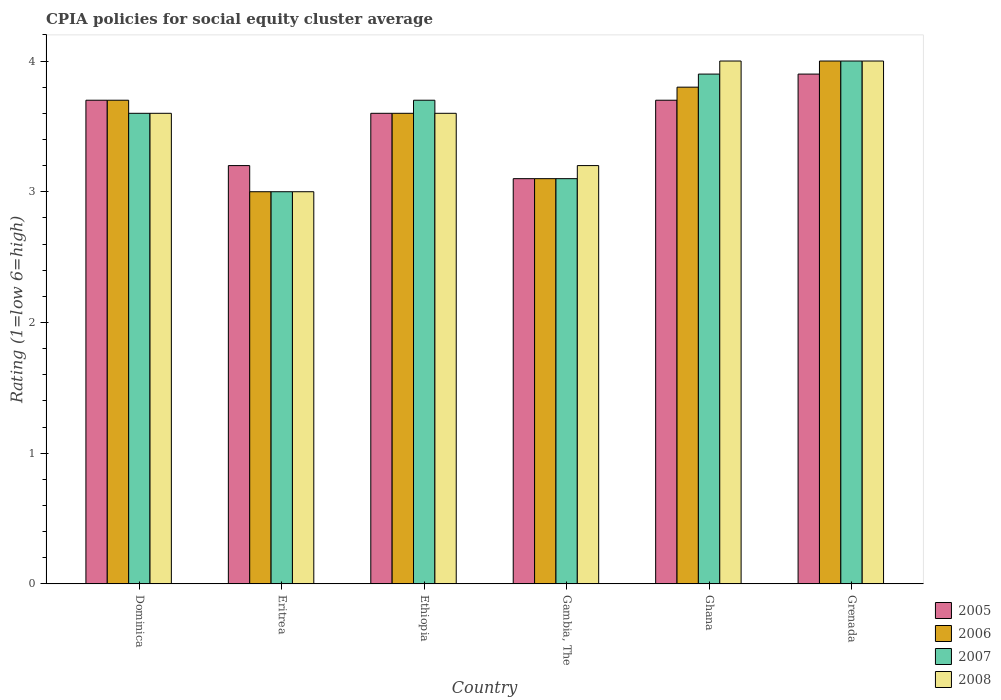How many different coloured bars are there?
Your response must be concise. 4. How many groups of bars are there?
Provide a short and direct response. 6. Are the number of bars on each tick of the X-axis equal?
Provide a succinct answer. Yes. How many bars are there on the 2nd tick from the left?
Provide a succinct answer. 4. How many bars are there on the 4th tick from the right?
Give a very brief answer. 4. What is the label of the 3rd group of bars from the left?
Your answer should be very brief. Ethiopia. In how many cases, is the number of bars for a given country not equal to the number of legend labels?
Your answer should be very brief. 0. What is the CPIA rating in 2005 in Gambia, The?
Provide a short and direct response. 3.1. Across all countries, what is the minimum CPIA rating in 2005?
Give a very brief answer. 3.1. In which country was the CPIA rating in 2005 maximum?
Your response must be concise. Grenada. In which country was the CPIA rating in 2005 minimum?
Offer a very short reply. Gambia, The. What is the total CPIA rating in 2005 in the graph?
Offer a terse response. 21.2. What is the difference between the CPIA rating in 2007 in Ethiopia and that in Gambia, The?
Your response must be concise. 0.6. What is the difference between the CPIA rating in 2006 in Ethiopia and the CPIA rating in 2005 in Ghana?
Your response must be concise. -0.1. What is the average CPIA rating in 2005 per country?
Your answer should be very brief. 3.53. What is the ratio of the CPIA rating in 2006 in Eritrea to that in Gambia, The?
Provide a short and direct response. 0.97. Is the CPIA rating in 2005 in Eritrea less than that in Ethiopia?
Offer a very short reply. Yes. What is the difference between the highest and the second highest CPIA rating in 2005?
Offer a very short reply. -0.2. In how many countries, is the CPIA rating in 2008 greater than the average CPIA rating in 2008 taken over all countries?
Provide a short and direct response. 4. What does the 1st bar from the left in Gambia, The represents?
Your answer should be compact. 2005. Is it the case that in every country, the sum of the CPIA rating in 2006 and CPIA rating in 2005 is greater than the CPIA rating in 2007?
Your answer should be compact. Yes. How many bars are there?
Your response must be concise. 24. Are the values on the major ticks of Y-axis written in scientific E-notation?
Provide a succinct answer. No. Does the graph contain any zero values?
Offer a very short reply. No. Does the graph contain grids?
Keep it short and to the point. No. How are the legend labels stacked?
Offer a terse response. Vertical. What is the title of the graph?
Your answer should be very brief. CPIA policies for social equity cluster average. What is the label or title of the X-axis?
Ensure brevity in your answer.  Country. What is the Rating (1=low 6=high) of 2005 in Dominica?
Your answer should be compact. 3.7. What is the Rating (1=low 6=high) in 2005 in Eritrea?
Keep it short and to the point. 3.2. What is the Rating (1=low 6=high) in 2006 in Eritrea?
Your answer should be very brief. 3. What is the Rating (1=low 6=high) of 2006 in Ethiopia?
Ensure brevity in your answer.  3.6. What is the Rating (1=low 6=high) in 2005 in Gambia, The?
Keep it short and to the point. 3.1. What is the Rating (1=low 6=high) in 2008 in Gambia, The?
Provide a succinct answer. 3.2. What is the Rating (1=low 6=high) in 2007 in Ghana?
Your answer should be very brief. 3.9. What is the Rating (1=low 6=high) of 2005 in Grenada?
Give a very brief answer. 3.9. What is the Rating (1=low 6=high) in 2007 in Grenada?
Offer a terse response. 4. Across all countries, what is the maximum Rating (1=low 6=high) in 2007?
Offer a terse response. 4. Across all countries, what is the minimum Rating (1=low 6=high) in 2006?
Your answer should be very brief. 3. Across all countries, what is the minimum Rating (1=low 6=high) in 2008?
Provide a short and direct response. 3. What is the total Rating (1=low 6=high) in 2005 in the graph?
Make the answer very short. 21.2. What is the total Rating (1=low 6=high) in 2006 in the graph?
Provide a succinct answer. 21.2. What is the total Rating (1=low 6=high) in 2007 in the graph?
Offer a very short reply. 21.3. What is the total Rating (1=low 6=high) in 2008 in the graph?
Offer a terse response. 21.4. What is the difference between the Rating (1=low 6=high) of 2005 in Dominica and that in Eritrea?
Provide a short and direct response. 0.5. What is the difference between the Rating (1=low 6=high) in 2007 in Dominica and that in Eritrea?
Your answer should be compact. 0.6. What is the difference between the Rating (1=low 6=high) of 2006 in Dominica and that in Ethiopia?
Your answer should be compact. 0.1. What is the difference between the Rating (1=low 6=high) of 2006 in Dominica and that in Gambia, The?
Your answer should be very brief. 0.6. What is the difference between the Rating (1=low 6=high) in 2007 in Dominica and that in Gambia, The?
Give a very brief answer. 0.5. What is the difference between the Rating (1=low 6=high) of 2006 in Dominica and that in Ghana?
Give a very brief answer. -0.1. What is the difference between the Rating (1=low 6=high) in 2007 in Dominica and that in Ghana?
Provide a succinct answer. -0.3. What is the difference between the Rating (1=low 6=high) in 2005 in Dominica and that in Grenada?
Provide a short and direct response. -0.2. What is the difference between the Rating (1=low 6=high) of 2006 in Dominica and that in Grenada?
Keep it short and to the point. -0.3. What is the difference between the Rating (1=low 6=high) of 2007 in Dominica and that in Grenada?
Provide a succinct answer. -0.4. What is the difference between the Rating (1=low 6=high) in 2005 in Eritrea and that in Gambia, The?
Your answer should be very brief. 0.1. What is the difference between the Rating (1=low 6=high) in 2006 in Eritrea and that in Gambia, The?
Give a very brief answer. -0.1. What is the difference between the Rating (1=low 6=high) in 2008 in Eritrea and that in Gambia, The?
Keep it short and to the point. -0.2. What is the difference between the Rating (1=low 6=high) of 2005 in Eritrea and that in Ghana?
Give a very brief answer. -0.5. What is the difference between the Rating (1=low 6=high) of 2006 in Eritrea and that in Ghana?
Make the answer very short. -0.8. What is the difference between the Rating (1=low 6=high) in 2008 in Eritrea and that in Ghana?
Ensure brevity in your answer.  -1. What is the difference between the Rating (1=low 6=high) in 2006 in Eritrea and that in Grenada?
Offer a very short reply. -1. What is the difference between the Rating (1=low 6=high) of 2008 in Eritrea and that in Grenada?
Your answer should be compact. -1. What is the difference between the Rating (1=low 6=high) in 2005 in Ethiopia and that in Gambia, The?
Provide a succinct answer. 0.5. What is the difference between the Rating (1=low 6=high) of 2008 in Ethiopia and that in Gambia, The?
Provide a succinct answer. 0.4. What is the difference between the Rating (1=low 6=high) of 2005 in Ethiopia and that in Ghana?
Make the answer very short. -0.1. What is the difference between the Rating (1=low 6=high) in 2008 in Ethiopia and that in Ghana?
Keep it short and to the point. -0.4. What is the difference between the Rating (1=low 6=high) in 2005 in Ethiopia and that in Grenada?
Offer a terse response. -0.3. What is the difference between the Rating (1=low 6=high) in 2007 in Ethiopia and that in Grenada?
Provide a short and direct response. -0.3. What is the difference between the Rating (1=low 6=high) in 2006 in Gambia, The and that in Ghana?
Provide a short and direct response. -0.7. What is the difference between the Rating (1=low 6=high) of 2008 in Gambia, The and that in Ghana?
Provide a short and direct response. -0.8. What is the difference between the Rating (1=low 6=high) in 2005 in Ghana and that in Grenada?
Your answer should be compact. -0.2. What is the difference between the Rating (1=low 6=high) of 2007 in Ghana and that in Grenada?
Offer a terse response. -0.1. What is the difference between the Rating (1=low 6=high) in 2005 in Dominica and the Rating (1=low 6=high) in 2007 in Eritrea?
Your answer should be compact. 0.7. What is the difference between the Rating (1=low 6=high) in 2005 in Dominica and the Rating (1=low 6=high) in 2008 in Eritrea?
Offer a very short reply. 0.7. What is the difference between the Rating (1=low 6=high) in 2005 in Dominica and the Rating (1=low 6=high) in 2006 in Ethiopia?
Offer a very short reply. 0.1. What is the difference between the Rating (1=low 6=high) in 2005 in Dominica and the Rating (1=low 6=high) in 2007 in Ethiopia?
Make the answer very short. 0. What is the difference between the Rating (1=low 6=high) of 2006 in Dominica and the Rating (1=low 6=high) of 2007 in Ethiopia?
Your answer should be very brief. 0. What is the difference between the Rating (1=low 6=high) in 2007 in Dominica and the Rating (1=low 6=high) in 2008 in Ethiopia?
Make the answer very short. 0. What is the difference between the Rating (1=low 6=high) of 2005 in Dominica and the Rating (1=low 6=high) of 2006 in Gambia, The?
Provide a succinct answer. 0.6. What is the difference between the Rating (1=low 6=high) in 2007 in Dominica and the Rating (1=low 6=high) in 2008 in Gambia, The?
Keep it short and to the point. 0.4. What is the difference between the Rating (1=low 6=high) of 2005 in Dominica and the Rating (1=low 6=high) of 2006 in Ghana?
Make the answer very short. -0.1. What is the difference between the Rating (1=low 6=high) in 2005 in Dominica and the Rating (1=low 6=high) in 2008 in Ghana?
Offer a very short reply. -0.3. What is the difference between the Rating (1=low 6=high) of 2006 in Dominica and the Rating (1=low 6=high) of 2007 in Ghana?
Your answer should be very brief. -0.2. What is the difference between the Rating (1=low 6=high) of 2006 in Dominica and the Rating (1=low 6=high) of 2008 in Ghana?
Your answer should be very brief. -0.3. What is the difference between the Rating (1=low 6=high) of 2007 in Dominica and the Rating (1=low 6=high) of 2008 in Ghana?
Keep it short and to the point. -0.4. What is the difference between the Rating (1=low 6=high) of 2006 in Dominica and the Rating (1=low 6=high) of 2007 in Grenada?
Your response must be concise. -0.3. What is the difference between the Rating (1=low 6=high) in 2005 in Eritrea and the Rating (1=low 6=high) in 2006 in Ethiopia?
Your answer should be very brief. -0.4. What is the difference between the Rating (1=low 6=high) in 2005 in Eritrea and the Rating (1=low 6=high) in 2007 in Ethiopia?
Your answer should be compact. -0.5. What is the difference between the Rating (1=low 6=high) in 2006 in Eritrea and the Rating (1=low 6=high) in 2007 in Ethiopia?
Your answer should be very brief. -0.7. What is the difference between the Rating (1=low 6=high) of 2007 in Eritrea and the Rating (1=low 6=high) of 2008 in Ethiopia?
Ensure brevity in your answer.  -0.6. What is the difference between the Rating (1=low 6=high) in 2005 in Eritrea and the Rating (1=low 6=high) in 2006 in Gambia, The?
Make the answer very short. 0.1. What is the difference between the Rating (1=low 6=high) in 2005 in Eritrea and the Rating (1=low 6=high) in 2008 in Gambia, The?
Make the answer very short. 0. What is the difference between the Rating (1=low 6=high) in 2006 in Eritrea and the Rating (1=low 6=high) in 2007 in Gambia, The?
Offer a terse response. -0.1. What is the difference between the Rating (1=low 6=high) in 2007 in Eritrea and the Rating (1=low 6=high) in 2008 in Gambia, The?
Give a very brief answer. -0.2. What is the difference between the Rating (1=low 6=high) of 2005 in Eritrea and the Rating (1=low 6=high) of 2007 in Ghana?
Your answer should be compact. -0.7. What is the difference between the Rating (1=low 6=high) in 2006 in Eritrea and the Rating (1=low 6=high) in 2007 in Ghana?
Provide a short and direct response. -0.9. What is the difference between the Rating (1=low 6=high) in 2007 in Eritrea and the Rating (1=low 6=high) in 2008 in Ghana?
Provide a succinct answer. -1. What is the difference between the Rating (1=low 6=high) of 2006 in Eritrea and the Rating (1=low 6=high) of 2007 in Grenada?
Offer a very short reply. -1. What is the difference between the Rating (1=low 6=high) of 2006 in Eritrea and the Rating (1=low 6=high) of 2008 in Grenada?
Your response must be concise. -1. What is the difference between the Rating (1=low 6=high) in 2007 in Eritrea and the Rating (1=low 6=high) in 2008 in Grenada?
Offer a very short reply. -1. What is the difference between the Rating (1=low 6=high) of 2005 in Ethiopia and the Rating (1=low 6=high) of 2006 in Gambia, The?
Ensure brevity in your answer.  0.5. What is the difference between the Rating (1=low 6=high) of 2005 in Ethiopia and the Rating (1=low 6=high) of 2008 in Gambia, The?
Provide a succinct answer. 0.4. What is the difference between the Rating (1=low 6=high) in 2006 in Ethiopia and the Rating (1=low 6=high) in 2008 in Gambia, The?
Ensure brevity in your answer.  0.4. What is the difference between the Rating (1=low 6=high) in 2007 in Ethiopia and the Rating (1=low 6=high) in 2008 in Gambia, The?
Offer a terse response. 0.5. What is the difference between the Rating (1=low 6=high) of 2005 in Ethiopia and the Rating (1=low 6=high) of 2006 in Ghana?
Ensure brevity in your answer.  -0.2. What is the difference between the Rating (1=low 6=high) in 2005 in Ethiopia and the Rating (1=low 6=high) in 2008 in Ghana?
Offer a very short reply. -0.4. What is the difference between the Rating (1=low 6=high) in 2006 in Ethiopia and the Rating (1=low 6=high) in 2008 in Ghana?
Keep it short and to the point. -0.4. What is the difference between the Rating (1=low 6=high) of 2007 in Ethiopia and the Rating (1=low 6=high) of 2008 in Ghana?
Your answer should be very brief. -0.3. What is the difference between the Rating (1=low 6=high) of 2005 in Ethiopia and the Rating (1=low 6=high) of 2006 in Grenada?
Ensure brevity in your answer.  -0.4. What is the difference between the Rating (1=low 6=high) in 2005 in Ethiopia and the Rating (1=low 6=high) in 2007 in Grenada?
Provide a short and direct response. -0.4. What is the difference between the Rating (1=low 6=high) of 2005 in Ethiopia and the Rating (1=low 6=high) of 2008 in Grenada?
Keep it short and to the point. -0.4. What is the difference between the Rating (1=low 6=high) of 2006 in Ethiopia and the Rating (1=low 6=high) of 2007 in Grenada?
Make the answer very short. -0.4. What is the difference between the Rating (1=low 6=high) in 2006 in Ethiopia and the Rating (1=low 6=high) in 2008 in Grenada?
Give a very brief answer. -0.4. What is the difference between the Rating (1=low 6=high) of 2005 in Gambia, The and the Rating (1=low 6=high) of 2008 in Ghana?
Keep it short and to the point. -0.9. What is the difference between the Rating (1=low 6=high) of 2006 in Gambia, The and the Rating (1=low 6=high) of 2008 in Ghana?
Offer a very short reply. -0.9. What is the difference between the Rating (1=low 6=high) in 2007 in Gambia, The and the Rating (1=low 6=high) in 2008 in Ghana?
Give a very brief answer. -0.9. What is the difference between the Rating (1=low 6=high) of 2005 in Gambia, The and the Rating (1=low 6=high) of 2006 in Grenada?
Your response must be concise. -0.9. What is the difference between the Rating (1=low 6=high) of 2006 in Gambia, The and the Rating (1=low 6=high) of 2007 in Grenada?
Offer a terse response. -0.9. What is the difference between the Rating (1=low 6=high) in 2007 in Gambia, The and the Rating (1=low 6=high) in 2008 in Grenada?
Ensure brevity in your answer.  -0.9. What is the difference between the Rating (1=low 6=high) of 2005 in Ghana and the Rating (1=low 6=high) of 2007 in Grenada?
Your answer should be compact. -0.3. What is the difference between the Rating (1=low 6=high) in 2006 in Ghana and the Rating (1=low 6=high) in 2007 in Grenada?
Provide a short and direct response. -0.2. What is the difference between the Rating (1=low 6=high) of 2007 in Ghana and the Rating (1=low 6=high) of 2008 in Grenada?
Your answer should be compact. -0.1. What is the average Rating (1=low 6=high) in 2005 per country?
Your answer should be compact. 3.53. What is the average Rating (1=low 6=high) of 2006 per country?
Offer a very short reply. 3.53. What is the average Rating (1=low 6=high) in 2007 per country?
Offer a terse response. 3.55. What is the average Rating (1=low 6=high) of 2008 per country?
Keep it short and to the point. 3.57. What is the difference between the Rating (1=low 6=high) of 2005 and Rating (1=low 6=high) of 2006 in Dominica?
Provide a succinct answer. 0. What is the difference between the Rating (1=low 6=high) in 2005 and Rating (1=low 6=high) in 2007 in Dominica?
Offer a terse response. 0.1. What is the difference between the Rating (1=low 6=high) of 2007 and Rating (1=low 6=high) of 2008 in Dominica?
Keep it short and to the point. 0. What is the difference between the Rating (1=low 6=high) of 2005 and Rating (1=low 6=high) of 2007 in Eritrea?
Give a very brief answer. 0.2. What is the difference between the Rating (1=low 6=high) of 2005 and Rating (1=low 6=high) of 2008 in Eritrea?
Provide a succinct answer. 0.2. What is the difference between the Rating (1=low 6=high) in 2006 and Rating (1=low 6=high) in 2007 in Eritrea?
Keep it short and to the point. 0. What is the difference between the Rating (1=low 6=high) in 2005 and Rating (1=low 6=high) in 2007 in Ethiopia?
Ensure brevity in your answer.  -0.1. What is the difference between the Rating (1=low 6=high) of 2005 and Rating (1=low 6=high) of 2008 in Ethiopia?
Offer a very short reply. 0. What is the difference between the Rating (1=low 6=high) of 2006 and Rating (1=low 6=high) of 2007 in Ethiopia?
Offer a terse response. -0.1. What is the difference between the Rating (1=low 6=high) of 2005 and Rating (1=low 6=high) of 2006 in Gambia, The?
Your answer should be very brief. 0. What is the difference between the Rating (1=low 6=high) in 2005 and Rating (1=low 6=high) in 2008 in Gambia, The?
Your answer should be very brief. -0.1. What is the difference between the Rating (1=low 6=high) in 2006 and Rating (1=low 6=high) in 2008 in Gambia, The?
Keep it short and to the point. -0.1. What is the difference between the Rating (1=low 6=high) of 2007 and Rating (1=low 6=high) of 2008 in Gambia, The?
Your answer should be compact. -0.1. What is the difference between the Rating (1=low 6=high) in 2005 and Rating (1=low 6=high) in 2006 in Ghana?
Ensure brevity in your answer.  -0.1. What is the difference between the Rating (1=low 6=high) in 2005 and Rating (1=low 6=high) in 2007 in Ghana?
Give a very brief answer. -0.2. What is the difference between the Rating (1=low 6=high) in 2005 and Rating (1=low 6=high) in 2008 in Ghana?
Make the answer very short. -0.3. What is the difference between the Rating (1=low 6=high) in 2005 and Rating (1=low 6=high) in 2007 in Grenada?
Give a very brief answer. -0.1. What is the difference between the Rating (1=low 6=high) of 2005 and Rating (1=low 6=high) of 2008 in Grenada?
Offer a very short reply. -0.1. What is the difference between the Rating (1=low 6=high) of 2006 and Rating (1=low 6=high) of 2007 in Grenada?
Your answer should be compact. 0. What is the difference between the Rating (1=low 6=high) in 2006 and Rating (1=low 6=high) in 2008 in Grenada?
Give a very brief answer. 0. What is the difference between the Rating (1=low 6=high) in 2007 and Rating (1=low 6=high) in 2008 in Grenada?
Provide a short and direct response. 0. What is the ratio of the Rating (1=low 6=high) of 2005 in Dominica to that in Eritrea?
Give a very brief answer. 1.16. What is the ratio of the Rating (1=low 6=high) of 2006 in Dominica to that in Eritrea?
Keep it short and to the point. 1.23. What is the ratio of the Rating (1=low 6=high) of 2007 in Dominica to that in Eritrea?
Your answer should be very brief. 1.2. What is the ratio of the Rating (1=low 6=high) of 2005 in Dominica to that in Ethiopia?
Ensure brevity in your answer.  1.03. What is the ratio of the Rating (1=low 6=high) in 2006 in Dominica to that in Ethiopia?
Provide a short and direct response. 1.03. What is the ratio of the Rating (1=low 6=high) of 2007 in Dominica to that in Ethiopia?
Your answer should be very brief. 0.97. What is the ratio of the Rating (1=low 6=high) in 2008 in Dominica to that in Ethiopia?
Provide a succinct answer. 1. What is the ratio of the Rating (1=low 6=high) of 2005 in Dominica to that in Gambia, The?
Make the answer very short. 1.19. What is the ratio of the Rating (1=low 6=high) in 2006 in Dominica to that in Gambia, The?
Give a very brief answer. 1.19. What is the ratio of the Rating (1=low 6=high) in 2007 in Dominica to that in Gambia, The?
Provide a short and direct response. 1.16. What is the ratio of the Rating (1=low 6=high) in 2006 in Dominica to that in Ghana?
Provide a succinct answer. 0.97. What is the ratio of the Rating (1=low 6=high) in 2005 in Dominica to that in Grenada?
Provide a short and direct response. 0.95. What is the ratio of the Rating (1=low 6=high) of 2006 in Dominica to that in Grenada?
Offer a terse response. 0.93. What is the ratio of the Rating (1=low 6=high) in 2007 in Dominica to that in Grenada?
Give a very brief answer. 0.9. What is the ratio of the Rating (1=low 6=high) of 2008 in Dominica to that in Grenada?
Keep it short and to the point. 0.9. What is the ratio of the Rating (1=low 6=high) of 2005 in Eritrea to that in Ethiopia?
Your response must be concise. 0.89. What is the ratio of the Rating (1=low 6=high) in 2007 in Eritrea to that in Ethiopia?
Provide a succinct answer. 0.81. What is the ratio of the Rating (1=low 6=high) of 2005 in Eritrea to that in Gambia, The?
Your response must be concise. 1.03. What is the ratio of the Rating (1=low 6=high) of 2007 in Eritrea to that in Gambia, The?
Your response must be concise. 0.97. What is the ratio of the Rating (1=low 6=high) of 2005 in Eritrea to that in Ghana?
Your response must be concise. 0.86. What is the ratio of the Rating (1=low 6=high) of 2006 in Eritrea to that in Ghana?
Your response must be concise. 0.79. What is the ratio of the Rating (1=low 6=high) of 2007 in Eritrea to that in Ghana?
Give a very brief answer. 0.77. What is the ratio of the Rating (1=low 6=high) of 2005 in Eritrea to that in Grenada?
Your response must be concise. 0.82. What is the ratio of the Rating (1=low 6=high) in 2007 in Eritrea to that in Grenada?
Offer a terse response. 0.75. What is the ratio of the Rating (1=low 6=high) of 2008 in Eritrea to that in Grenada?
Your answer should be very brief. 0.75. What is the ratio of the Rating (1=low 6=high) in 2005 in Ethiopia to that in Gambia, The?
Give a very brief answer. 1.16. What is the ratio of the Rating (1=low 6=high) of 2006 in Ethiopia to that in Gambia, The?
Give a very brief answer. 1.16. What is the ratio of the Rating (1=low 6=high) in 2007 in Ethiopia to that in Gambia, The?
Give a very brief answer. 1.19. What is the ratio of the Rating (1=low 6=high) of 2008 in Ethiopia to that in Gambia, The?
Give a very brief answer. 1.12. What is the ratio of the Rating (1=low 6=high) in 2007 in Ethiopia to that in Ghana?
Your response must be concise. 0.95. What is the ratio of the Rating (1=low 6=high) in 2005 in Ethiopia to that in Grenada?
Your answer should be compact. 0.92. What is the ratio of the Rating (1=low 6=high) of 2006 in Ethiopia to that in Grenada?
Your answer should be compact. 0.9. What is the ratio of the Rating (1=low 6=high) in 2007 in Ethiopia to that in Grenada?
Your answer should be very brief. 0.93. What is the ratio of the Rating (1=low 6=high) in 2005 in Gambia, The to that in Ghana?
Your response must be concise. 0.84. What is the ratio of the Rating (1=low 6=high) in 2006 in Gambia, The to that in Ghana?
Your answer should be very brief. 0.82. What is the ratio of the Rating (1=low 6=high) in 2007 in Gambia, The to that in Ghana?
Provide a short and direct response. 0.79. What is the ratio of the Rating (1=low 6=high) in 2005 in Gambia, The to that in Grenada?
Offer a very short reply. 0.79. What is the ratio of the Rating (1=low 6=high) of 2006 in Gambia, The to that in Grenada?
Provide a succinct answer. 0.78. What is the ratio of the Rating (1=low 6=high) in 2007 in Gambia, The to that in Grenada?
Provide a succinct answer. 0.78. What is the ratio of the Rating (1=low 6=high) of 2005 in Ghana to that in Grenada?
Provide a succinct answer. 0.95. What is the ratio of the Rating (1=low 6=high) in 2007 in Ghana to that in Grenada?
Offer a terse response. 0.97. What is the difference between the highest and the second highest Rating (1=low 6=high) in 2005?
Your answer should be compact. 0.2. What is the difference between the highest and the second highest Rating (1=low 6=high) in 2007?
Your answer should be very brief. 0.1. What is the difference between the highest and the second highest Rating (1=low 6=high) of 2008?
Keep it short and to the point. 0. What is the difference between the highest and the lowest Rating (1=low 6=high) in 2005?
Your answer should be compact. 0.8. What is the difference between the highest and the lowest Rating (1=low 6=high) of 2006?
Your response must be concise. 1. What is the difference between the highest and the lowest Rating (1=low 6=high) in 2007?
Offer a very short reply. 1. 